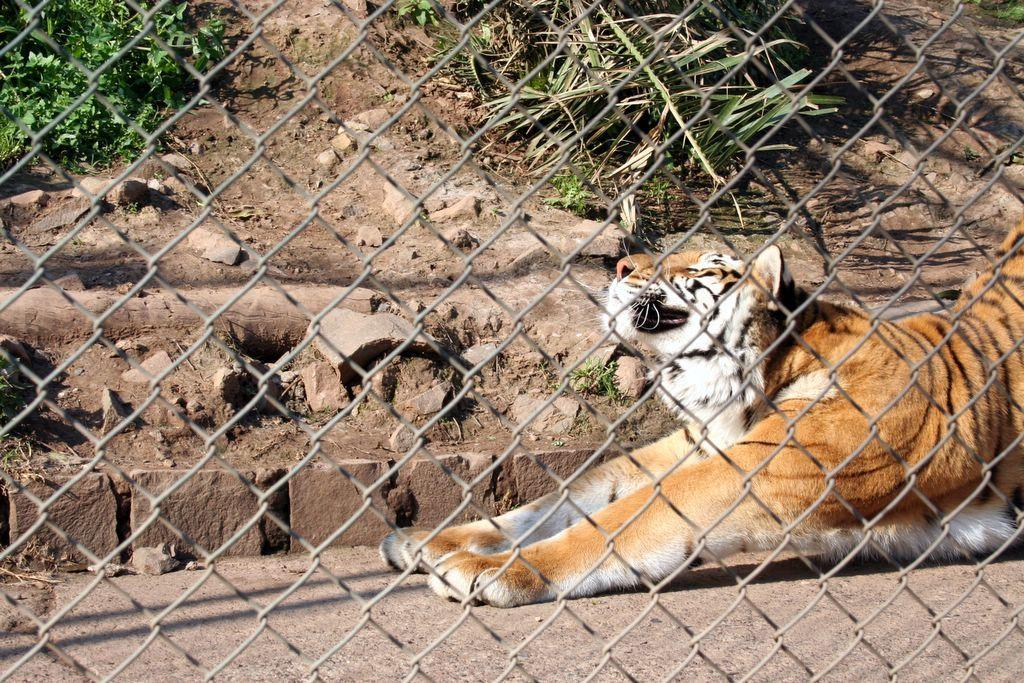What animal can be seen on the right side of the image? There is a tiger on the right side of the image. What is the purpose of the iron net in the image? The iron net is likely used to contain or protect the tiger. What type of vegetation is visible at the top of the image? There are trees visible at the top of the image. What note is the tiger playing on the musical instrument in the image? There is no musical instrument present in the image, and therefore the tiger is not playing any notes. 